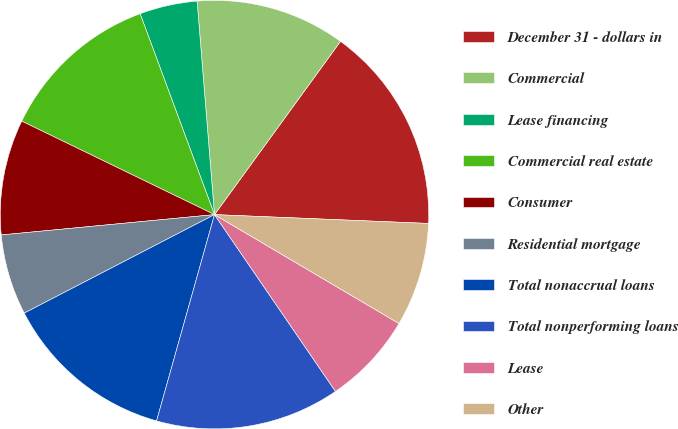<chart> <loc_0><loc_0><loc_500><loc_500><pie_chart><fcel>December 31 - dollars in<fcel>Commercial<fcel>Lease financing<fcel>Commercial real estate<fcel>Consumer<fcel>Residential mortgage<fcel>Total nonaccrual loans<fcel>Total nonperforming loans<fcel>Lease<fcel>Other<nl><fcel>15.65%<fcel>11.3%<fcel>4.35%<fcel>12.17%<fcel>8.7%<fcel>6.09%<fcel>13.04%<fcel>13.91%<fcel>6.96%<fcel>7.83%<nl></chart> 